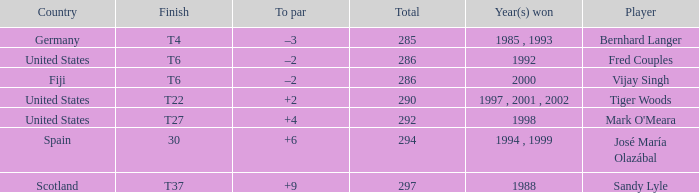Which player has +2 to par? Tiger Woods. 